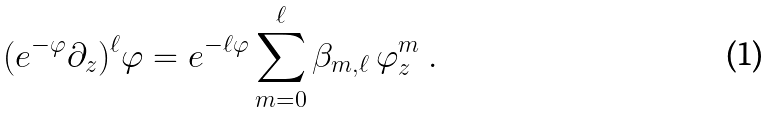Convert formula to latex. <formula><loc_0><loc_0><loc_500><loc_500>( e ^ { - \varphi } \partial _ { z } ) ^ { \ell } \varphi = e ^ { - \ell \varphi } \sum _ { m = 0 } ^ { \ell } \beta _ { m , \ell } \, \varphi _ { z } ^ { m } \ .</formula> 